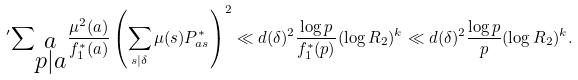<formula> <loc_0><loc_0><loc_500><loc_500>{ ^ { \prime } } { \sum } _ { \substack { a \\ p | a } } \frac { \mu ^ { 2 } ( a ) } { f _ { 1 } ^ { * } ( a ) } \left ( \sum _ { s | \delta } \mu ( s ) P _ { a s } ^ { * } \right ) ^ { 2 } \ll d ( \delta ) ^ { 2 } \frac { \log { p } } { f _ { 1 } ^ { * } ( p ) } ( \log { R _ { 2 } } ) ^ { k } \ll d ( \delta ) ^ { 2 } \frac { \log { p } } { p } ( \log { R _ { 2 } } ) ^ { k } .</formula> 